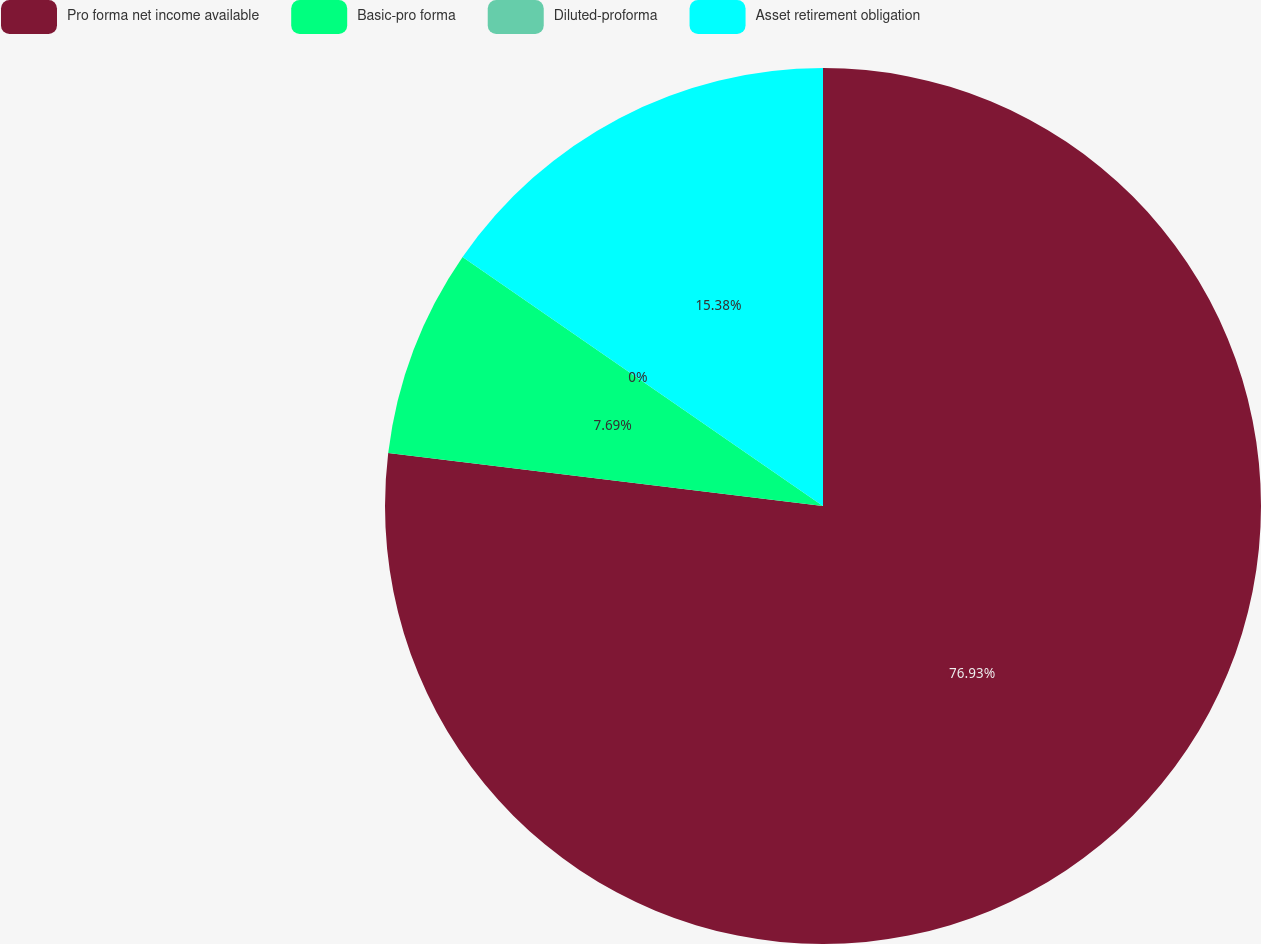<chart> <loc_0><loc_0><loc_500><loc_500><pie_chart><fcel>Pro forma net income available<fcel>Basic-pro forma<fcel>Diluted-proforma<fcel>Asset retirement obligation<nl><fcel>76.92%<fcel>7.69%<fcel>0.0%<fcel>15.38%<nl></chart> 